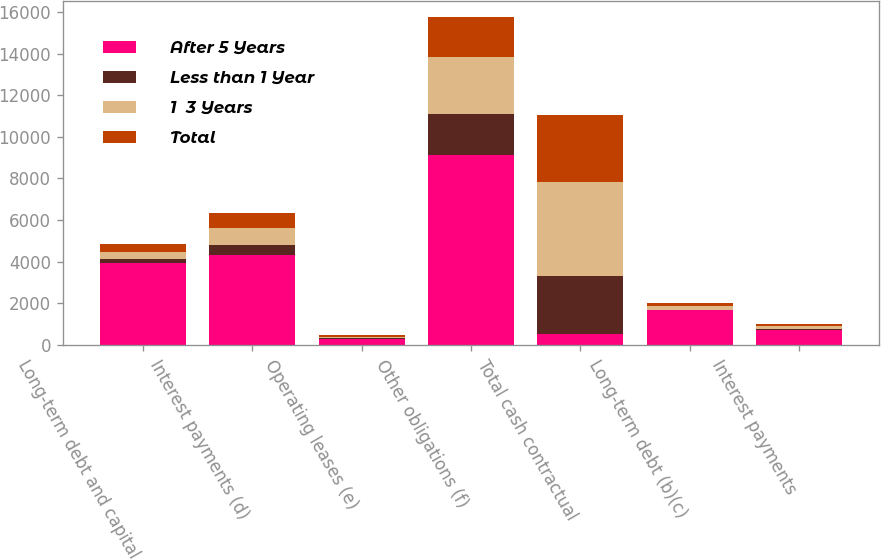<chart> <loc_0><loc_0><loc_500><loc_500><stacked_bar_chart><ecel><fcel>Long-term debt and capital<fcel>Interest payments (d)<fcel>Operating leases (e)<fcel>Other obligations (f)<fcel>Total cash contractual<fcel>Long-term debt (b)(c)<fcel>Interest payments<nl><fcel>After 5 Years<fcel>3955<fcel>4338<fcel>307<fcel>9114<fcel>515<fcel>1661<fcel>710<nl><fcel>Less than 1 Year<fcel>178<fcel>446<fcel>38<fcel>1972<fcel>2783<fcel>1<fcel>59<nl><fcel>1  3 Years<fcel>314<fcel>826<fcel>58<fcel>2727<fcel>4551<fcel>201<fcel>118<nl><fcel>Total<fcel>386<fcel>715<fcel>51<fcel>1929<fcel>3210<fcel>129<fcel>118<nl></chart> 